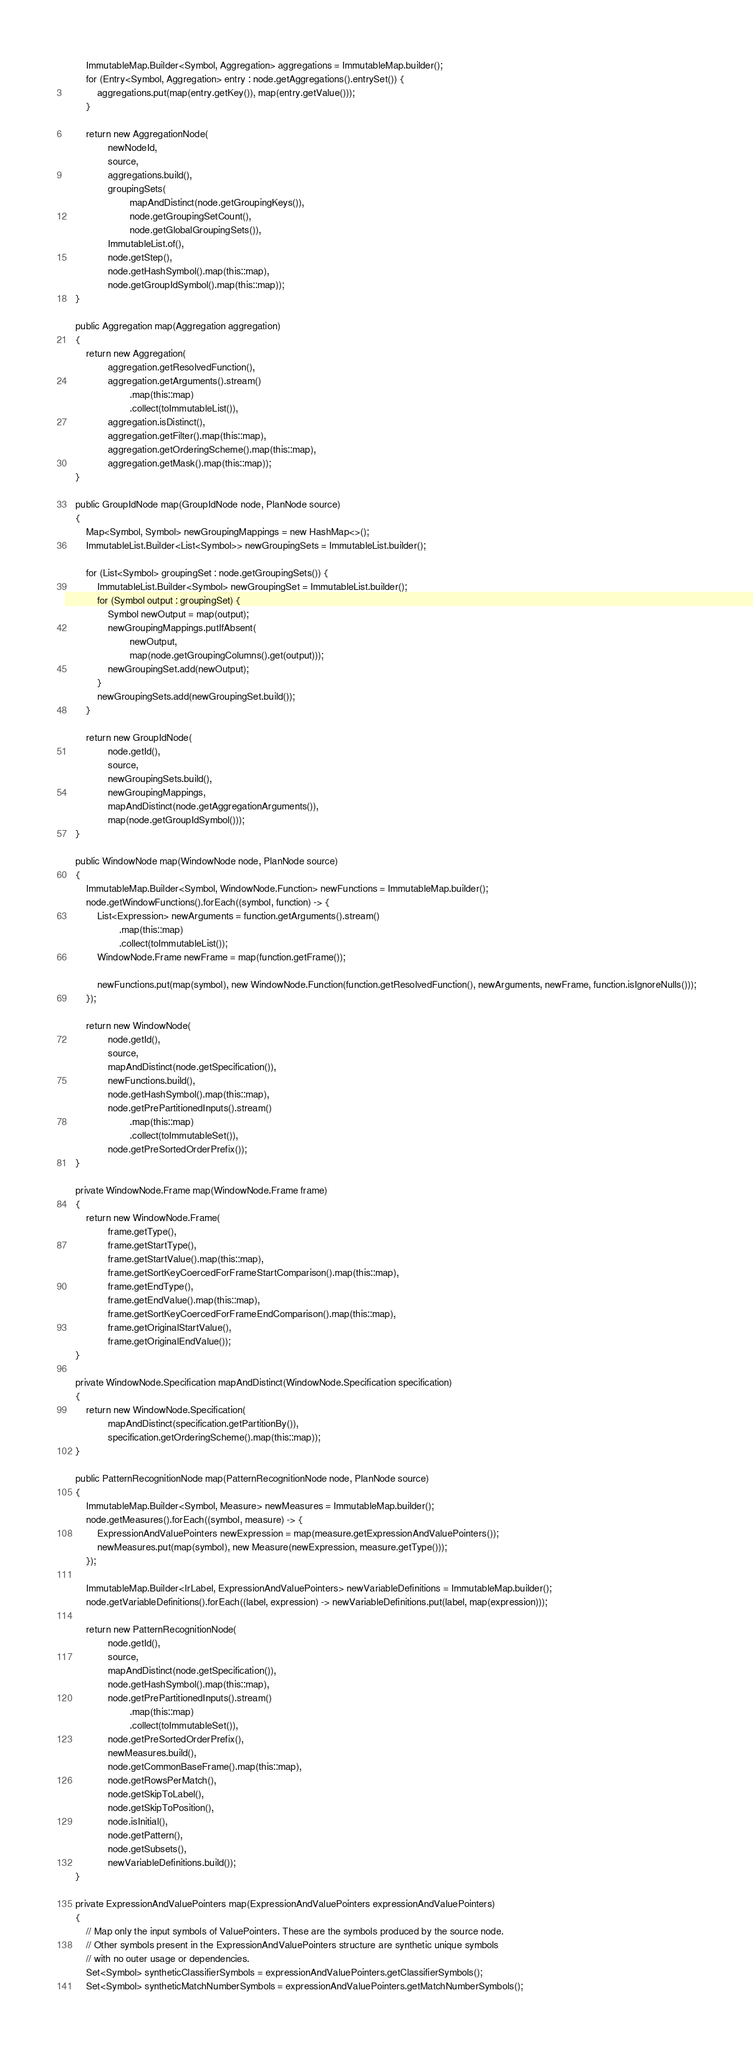<code> <loc_0><loc_0><loc_500><loc_500><_Java_>        ImmutableMap.Builder<Symbol, Aggregation> aggregations = ImmutableMap.builder();
        for (Entry<Symbol, Aggregation> entry : node.getAggregations().entrySet()) {
            aggregations.put(map(entry.getKey()), map(entry.getValue()));
        }

        return new AggregationNode(
                newNodeId,
                source,
                aggregations.build(),
                groupingSets(
                        mapAndDistinct(node.getGroupingKeys()),
                        node.getGroupingSetCount(),
                        node.getGlobalGroupingSets()),
                ImmutableList.of(),
                node.getStep(),
                node.getHashSymbol().map(this::map),
                node.getGroupIdSymbol().map(this::map));
    }

    public Aggregation map(Aggregation aggregation)
    {
        return new Aggregation(
                aggregation.getResolvedFunction(),
                aggregation.getArguments().stream()
                        .map(this::map)
                        .collect(toImmutableList()),
                aggregation.isDistinct(),
                aggregation.getFilter().map(this::map),
                aggregation.getOrderingScheme().map(this::map),
                aggregation.getMask().map(this::map));
    }

    public GroupIdNode map(GroupIdNode node, PlanNode source)
    {
        Map<Symbol, Symbol> newGroupingMappings = new HashMap<>();
        ImmutableList.Builder<List<Symbol>> newGroupingSets = ImmutableList.builder();

        for (List<Symbol> groupingSet : node.getGroupingSets()) {
            ImmutableList.Builder<Symbol> newGroupingSet = ImmutableList.builder();
            for (Symbol output : groupingSet) {
                Symbol newOutput = map(output);
                newGroupingMappings.putIfAbsent(
                        newOutput,
                        map(node.getGroupingColumns().get(output)));
                newGroupingSet.add(newOutput);
            }
            newGroupingSets.add(newGroupingSet.build());
        }

        return new GroupIdNode(
                node.getId(),
                source,
                newGroupingSets.build(),
                newGroupingMappings,
                mapAndDistinct(node.getAggregationArguments()),
                map(node.getGroupIdSymbol()));
    }

    public WindowNode map(WindowNode node, PlanNode source)
    {
        ImmutableMap.Builder<Symbol, WindowNode.Function> newFunctions = ImmutableMap.builder();
        node.getWindowFunctions().forEach((symbol, function) -> {
            List<Expression> newArguments = function.getArguments().stream()
                    .map(this::map)
                    .collect(toImmutableList());
            WindowNode.Frame newFrame = map(function.getFrame());

            newFunctions.put(map(symbol), new WindowNode.Function(function.getResolvedFunction(), newArguments, newFrame, function.isIgnoreNulls()));
        });

        return new WindowNode(
                node.getId(),
                source,
                mapAndDistinct(node.getSpecification()),
                newFunctions.build(),
                node.getHashSymbol().map(this::map),
                node.getPrePartitionedInputs().stream()
                        .map(this::map)
                        .collect(toImmutableSet()),
                node.getPreSortedOrderPrefix());
    }

    private WindowNode.Frame map(WindowNode.Frame frame)
    {
        return new WindowNode.Frame(
                frame.getType(),
                frame.getStartType(),
                frame.getStartValue().map(this::map),
                frame.getSortKeyCoercedForFrameStartComparison().map(this::map),
                frame.getEndType(),
                frame.getEndValue().map(this::map),
                frame.getSortKeyCoercedForFrameEndComparison().map(this::map),
                frame.getOriginalStartValue(),
                frame.getOriginalEndValue());
    }

    private WindowNode.Specification mapAndDistinct(WindowNode.Specification specification)
    {
        return new WindowNode.Specification(
                mapAndDistinct(specification.getPartitionBy()),
                specification.getOrderingScheme().map(this::map));
    }

    public PatternRecognitionNode map(PatternRecognitionNode node, PlanNode source)
    {
        ImmutableMap.Builder<Symbol, Measure> newMeasures = ImmutableMap.builder();
        node.getMeasures().forEach((symbol, measure) -> {
            ExpressionAndValuePointers newExpression = map(measure.getExpressionAndValuePointers());
            newMeasures.put(map(symbol), new Measure(newExpression, measure.getType()));
        });

        ImmutableMap.Builder<IrLabel, ExpressionAndValuePointers> newVariableDefinitions = ImmutableMap.builder();
        node.getVariableDefinitions().forEach((label, expression) -> newVariableDefinitions.put(label, map(expression)));

        return new PatternRecognitionNode(
                node.getId(),
                source,
                mapAndDistinct(node.getSpecification()),
                node.getHashSymbol().map(this::map),
                node.getPrePartitionedInputs().stream()
                        .map(this::map)
                        .collect(toImmutableSet()),
                node.getPreSortedOrderPrefix(),
                newMeasures.build(),
                node.getCommonBaseFrame().map(this::map),
                node.getRowsPerMatch(),
                node.getSkipToLabel(),
                node.getSkipToPosition(),
                node.isInitial(),
                node.getPattern(),
                node.getSubsets(),
                newVariableDefinitions.build());
    }

    private ExpressionAndValuePointers map(ExpressionAndValuePointers expressionAndValuePointers)
    {
        // Map only the input symbols of ValuePointers. These are the symbols produced by the source node.
        // Other symbols present in the ExpressionAndValuePointers structure are synthetic unique symbols
        // with no outer usage or dependencies.
        Set<Symbol> syntheticClassifierSymbols = expressionAndValuePointers.getClassifierSymbols();
        Set<Symbol> syntheticMatchNumberSymbols = expressionAndValuePointers.getMatchNumberSymbols();
</code> 